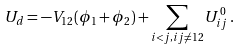Convert formula to latex. <formula><loc_0><loc_0><loc_500><loc_500>U _ { d } = - V _ { 1 2 } ( \phi _ { 1 } + \phi _ { 2 } ) + \sum _ { i < j , i j \neq 1 2 } U ^ { 0 } _ { i j } \, .</formula> 